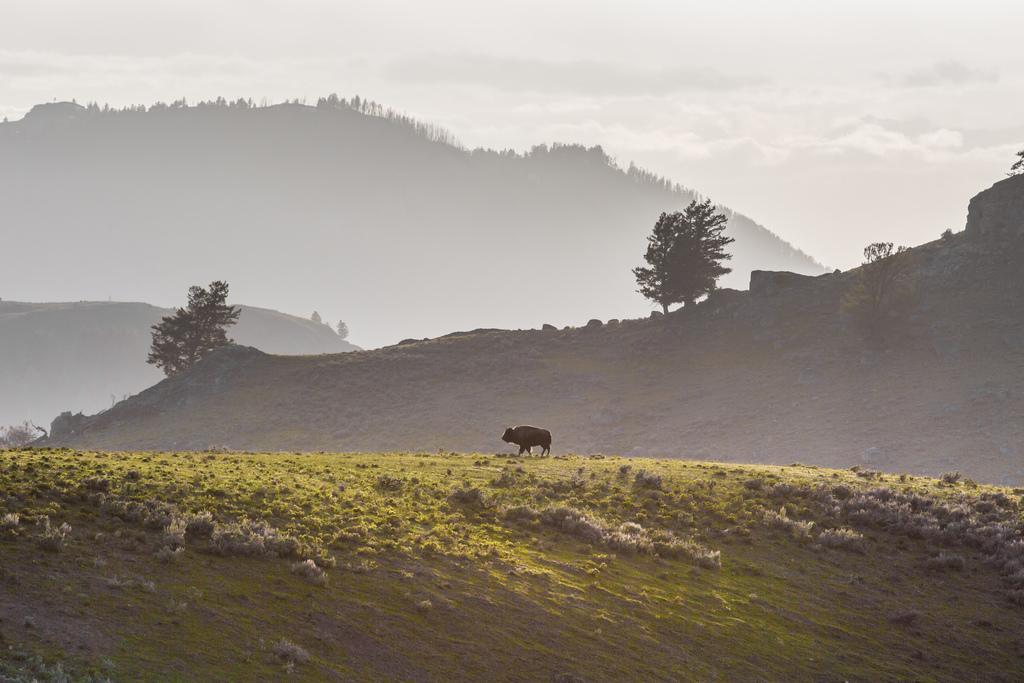Can you describe this image briefly? In this image we can see an animal which is walking and at the background of the image there are some trees, mountains and cloudy sky. 